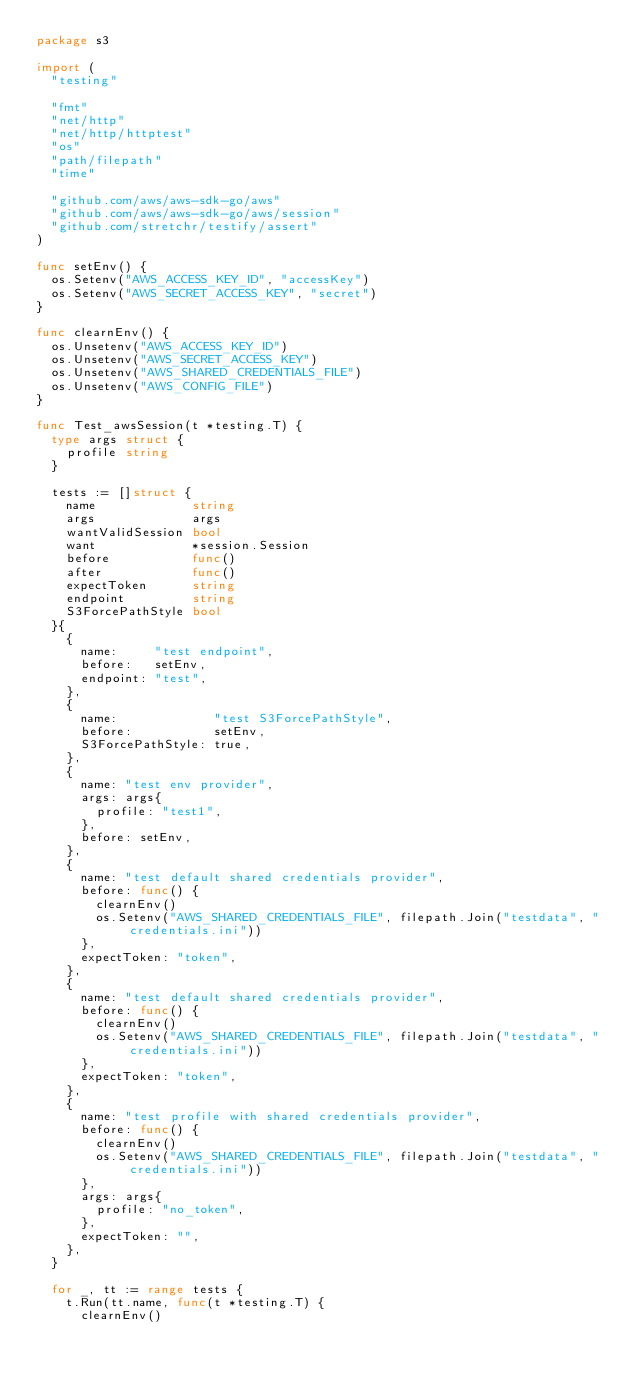<code> <loc_0><loc_0><loc_500><loc_500><_Go_>package s3

import (
	"testing"

	"fmt"
	"net/http"
	"net/http/httptest"
	"os"
	"path/filepath"
	"time"

	"github.com/aws/aws-sdk-go/aws"
	"github.com/aws/aws-sdk-go/aws/session"
	"github.com/stretchr/testify/assert"
)

func setEnv() {
	os.Setenv("AWS_ACCESS_KEY_ID", "accessKey")
	os.Setenv("AWS_SECRET_ACCESS_KEY", "secret")
}

func clearnEnv() {
	os.Unsetenv("AWS_ACCESS_KEY_ID")
	os.Unsetenv("AWS_SECRET_ACCESS_KEY")
	os.Unsetenv("AWS_SHARED_CREDENTIALS_FILE")
	os.Unsetenv("AWS_CONFIG_FILE")
}

func Test_awsSession(t *testing.T) {
	type args struct {
		profile string
	}

	tests := []struct {
		name             string
		args             args
		wantValidSession bool
		want             *session.Session
		before           func()
		after            func()
		expectToken      string
		endpoint         string
		S3ForcePathStyle bool
	}{
		{
			name:     "test endpoint",
			before:   setEnv,
			endpoint: "test",
		},
		{
			name:             "test S3ForcePathStyle",
			before:           setEnv,
			S3ForcePathStyle: true,
		},
		{
			name: "test env provider",
			args: args{
				profile: "test1",
			},
			before: setEnv,
		},
		{
			name: "test default shared credentials provider",
			before: func() {
				clearnEnv()
				os.Setenv("AWS_SHARED_CREDENTIALS_FILE", filepath.Join("testdata", "credentials.ini"))
			},
			expectToken: "token",
		},
		{
			name: "test default shared credentials provider",
			before: func() {
				clearnEnv()
				os.Setenv("AWS_SHARED_CREDENTIALS_FILE", filepath.Join("testdata", "credentials.ini"))
			},
			expectToken: "token",
		},
		{
			name: "test profile with shared credentials provider",
			before: func() {
				clearnEnv()
				os.Setenv("AWS_SHARED_CREDENTIALS_FILE", filepath.Join("testdata", "credentials.ini"))
			},
			args: args{
				profile: "no_token",
			},
			expectToken: "",
		},
	}

	for _, tt := range tests {
		t.Run(tt.name, func(t *testing.T) {
			clearnEnv()</code> 